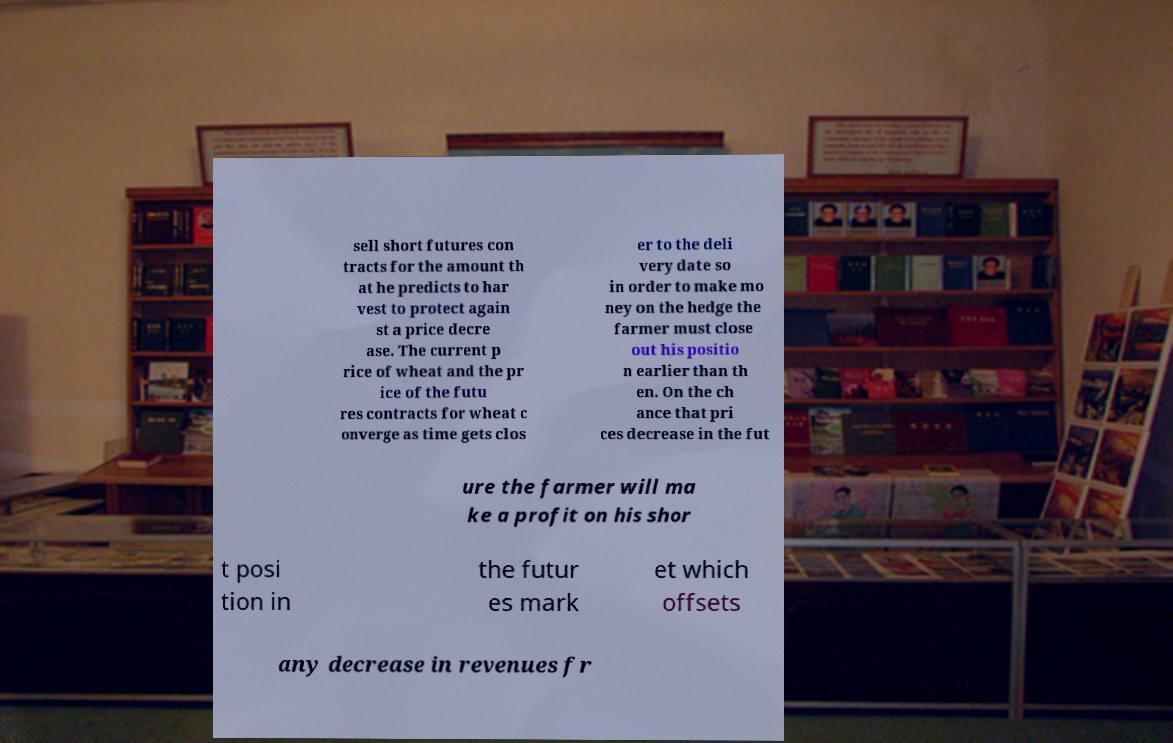Can you read and provide the text displayed in the image?This photo seems to have some interesting text. Can you extract and type it out for me? sell short futures con tracts for the amount th at he predicts to har vest to protect again st a price decre ase. The current p rice of wheat and the pr ice of the futu res contracts for wheat c onverge as time gets clos er to the deli very date so in order to make mo ney on the hedge the farmer must close out his positio n earlier than th en. On the ch ance that pri ces decrease in the fut ure the farmer will ma ke a profit on his shor t posi tion in the futur es mark et which offsets any decrease in revenues fr 